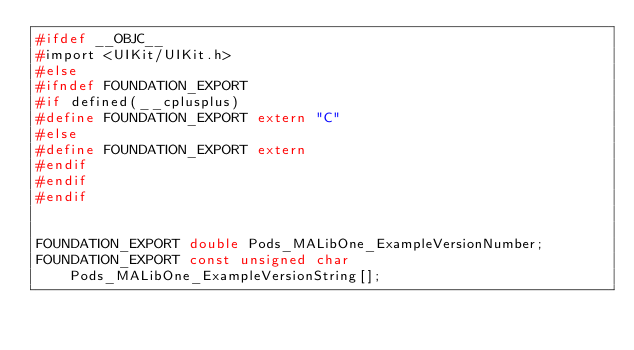<code> <loc_0><loc_0><loc_500><loc_500><_C_>#ifdef __OBJC__
#import <UIKit/UIKit.h>
#else
#ifndef FOUNDATION_EXPORT
#if defined(__cplusplus)
#define FOUNDATION_EXPORT extern "C"
#else
#define FOUNDATION_EXPORT extern
#endif
#endif
#endif


FOUNDATION_EXPORT double Pods_MALibOne_ExampleVersionNumber;
FOUNDATION_EXPORT const unsigned char Pods_MALibOne_ExampleVersionString[];

</code> 